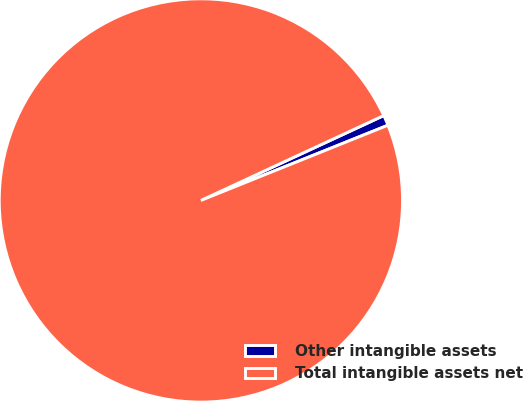<chart> <loc_0><loc_0><loc_500><loc_500><pie_chart><fcel>Other intangible assets<fcel>Total intangible assets net<nl><fcel>0.83%<fcel>99.17%<nl></chart> 